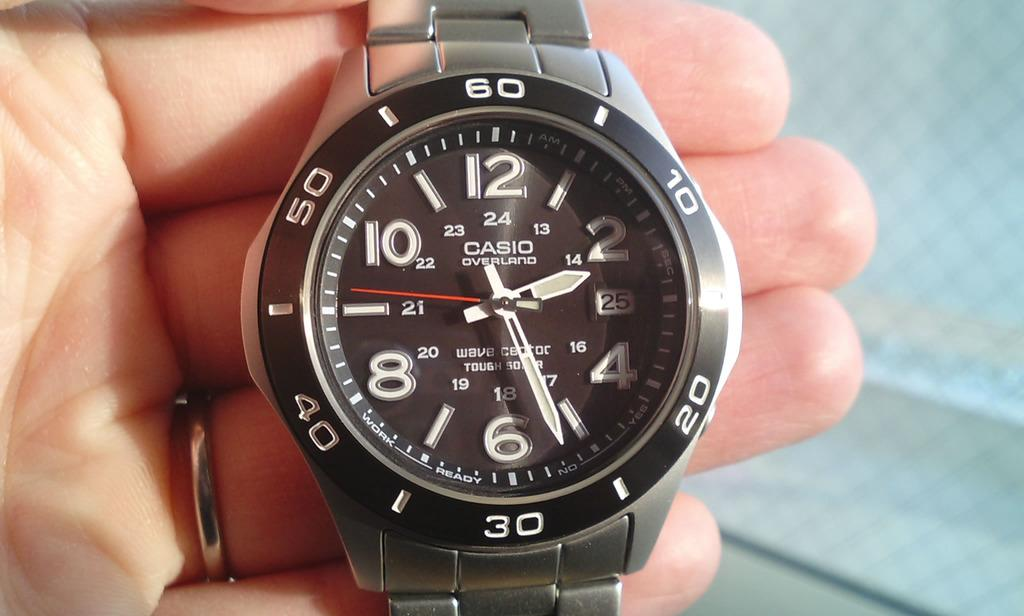<image>
Share a concise interpretation of the image provided. A black faced watch by Casio has the time of 2:27. 